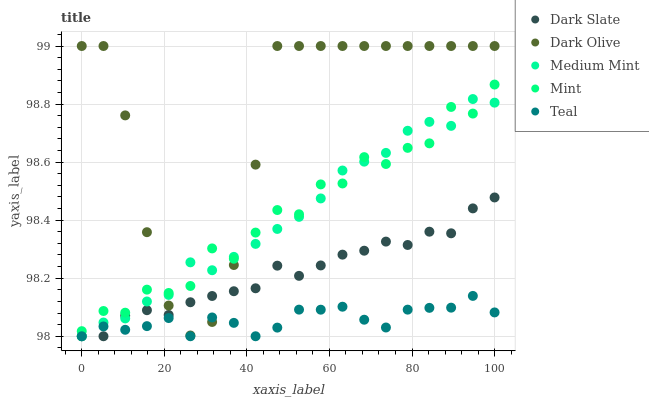Does Teal have the minimum area under the curve?
Answer yes or no. Yes. Does Dark Olive have the maximum area under the curve?
Answer yes or no. Yes. Does Dark Slate have the minimum area under the curve?
Answer yes or no. No. Does Dark Slate have the maximum area under the curve?
Answer yes or no. No. Is Dark Slate the smoothest?
Answer yes or no. Yes. Is Mint the roughest?
Answer yes or no. Yes. Is Dark Olive the smoothest?
Answer yes or no. No. Is Dark Olive the roughest?
Answer yes or no. No. Does Medium Mint have the lowest value?
Answer yes or no. Yes. Does Dark Olive have the lowest value?
Answer yes or no. No. Does Dark Olive have the highest value?
Answer yes or no. Yes. Does Dark Slate have the highest value?
Answer yes or no. No. Is Teal less than Mint?
Answer yes or no. Yes. Is Mint greater than Dark Slate?
Answer yes or no. Yes. Does Dark Olive intersect Mint?
Answer yes or no. Yes. Is Dark Olive less than Mint?
Answer yes or no. No. Is Dark Olive greater than Mint?
Answer yes or no. No. Does Teal intersect Mint?
Answer yes or no. No. 